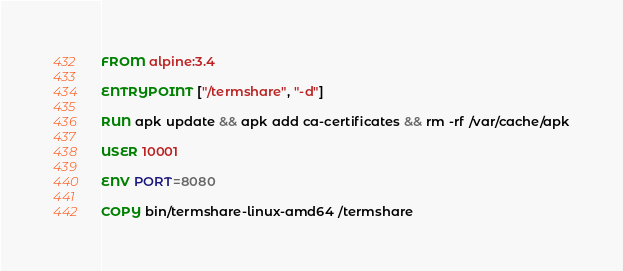Convert code to text. <code><loc_0><loc_0><loc_500><loc_500><_Dockerfile_>FROM alpine:3.4

ENTRYPOINT ["/termshare", "-d"]

RUN apk update && apk add ca-certificates && rm -rf /var/cache/apk

USER 10001

ENV PORT=8080

COPY bin/termshare-linux-amd64 /termshare

</code> 